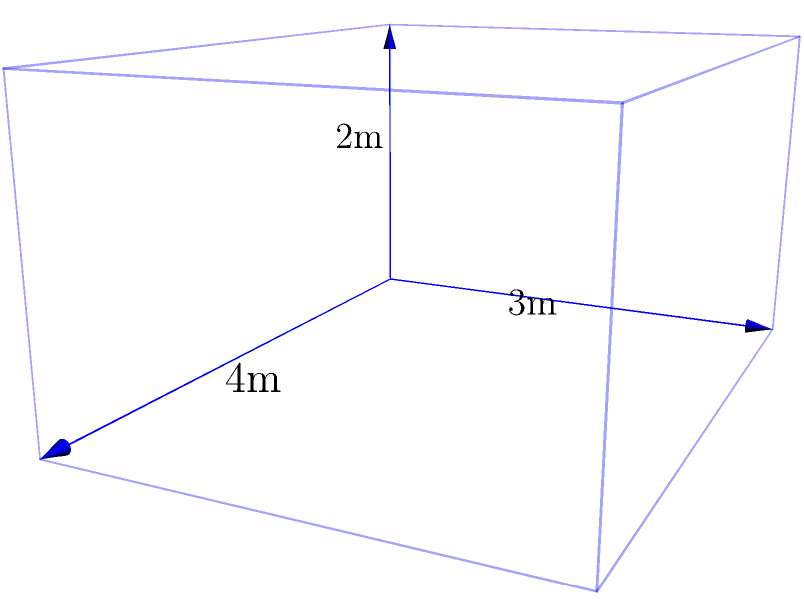An animal sanctuary is designing a new cuboid-shaped enclosure for rescued rabbits. The enclosure measures 4m in length, 3m in width, and 2m in height. To ensure the rabbits' comfort, the sanctuary plans to line the entire interior surface (including the floor) with soft, eco-friendly padding. How many square meters of padding material will be needed to cover the entire interior surface of the enclosure? Let's approach this step-by-step:

1) First, we need to calculate the surface area of the cuboid. The surface area of a cuboid is the sum of the areas of all six faces.

2) The cuboid has three pairs of identical faces:
   - Two length-width faces (top and bottom)
   - Two length-height faces (front and back)
   - Two width-height faces (left and right sides)

3) Let's calculate the area of each pair:
   - Length-width faces: $4m \times 3m = 12m^2$ each, $12m^2 \times 2 = 24m^2$ for both
   - Length-height faces: $4m \times 2m = 8m^2$ each, $8m^2 \times 2 = 16m^2$ for both
   - Width-height faces: $3m \times 2m = 6m^2$ each, $6m^2 \times 2 = 12m^2$ for both

4) Now, we sum up all the areas:
   $24m^2 + 16m^2 + 12m^2 = 52m^2$

5) Therefore, the total surface area of the interior of the enclosure is $52m^2$.

This means the sanctuary will need 52 square meters of padding material to cover the entire interior surface of the enclosure, providing a comfortable and safe environment for the rescued rabbits.
Answer: $52m^2$ 